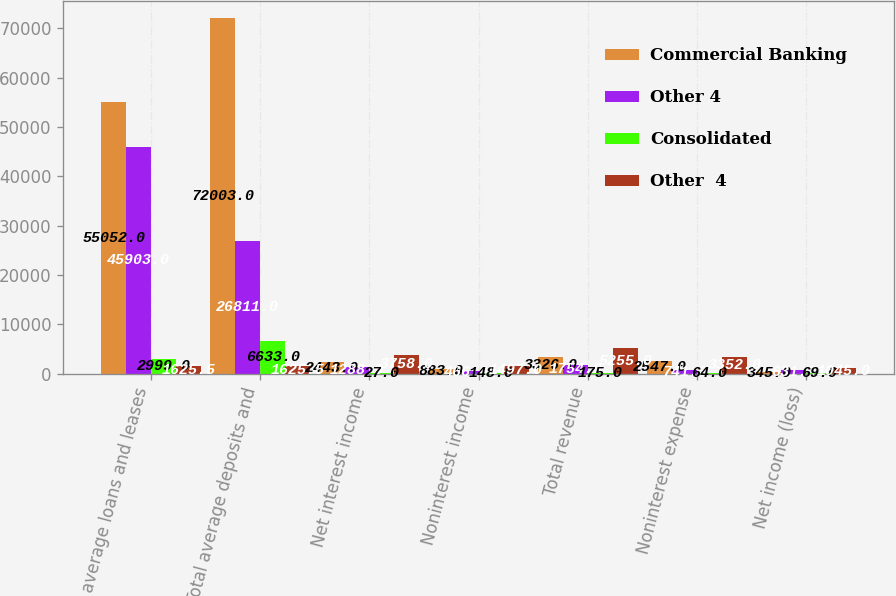<chart> <loc_0><loc_0><loc_500><loc_500><stacked_bar_chart><ecel><fcel>Total average loans and leases<fcel>Total average deposits and<fcel>Net interest income<fcel>Noninterest income<fcel>Total revenue<fcel>Noninterest expense<fcel>Net income (loss)<nl><fcel>Commercial Banking<fcel>55052<fcel>72003<fcel>2443<fcel>883<fcel>3326<fcel>2547<fcel>345<nl><fcel>Other 4<fcel>45903<fcel>26811<fcel>1288<fcel>466<fcel>1754<fcel>741<fcel>631<nl><fcel>Consolidated<fcel>2999<fcel>6633<fcel>27<fcel>148<fcel>175<fcel>64<fcel>69<nl><fcel>Other  4<fcel>1625.5<fcel>1625.5<fcel>3758<fcel>1497<fcel>5255<fcel>3352<fcel>1045<nl></chart> 